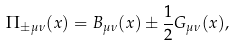Convert formula to latex. <formula><loc_0><loc_0><loc_500><loc_500>\Pi _ { \pm \mu \nu } ( x ) = B _ { \mu \nu } ( x ) \pm \frac { 1 } { 2 } G _ { \mu \nu } ( x ) ,</formula> 